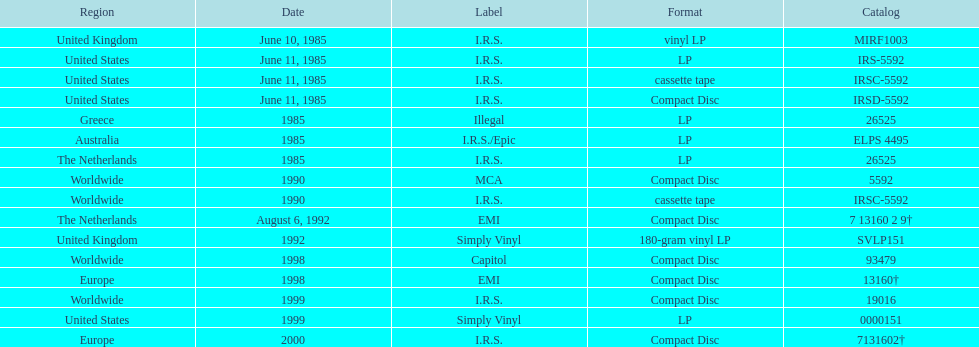How many occurrences was the album issued? 13. 